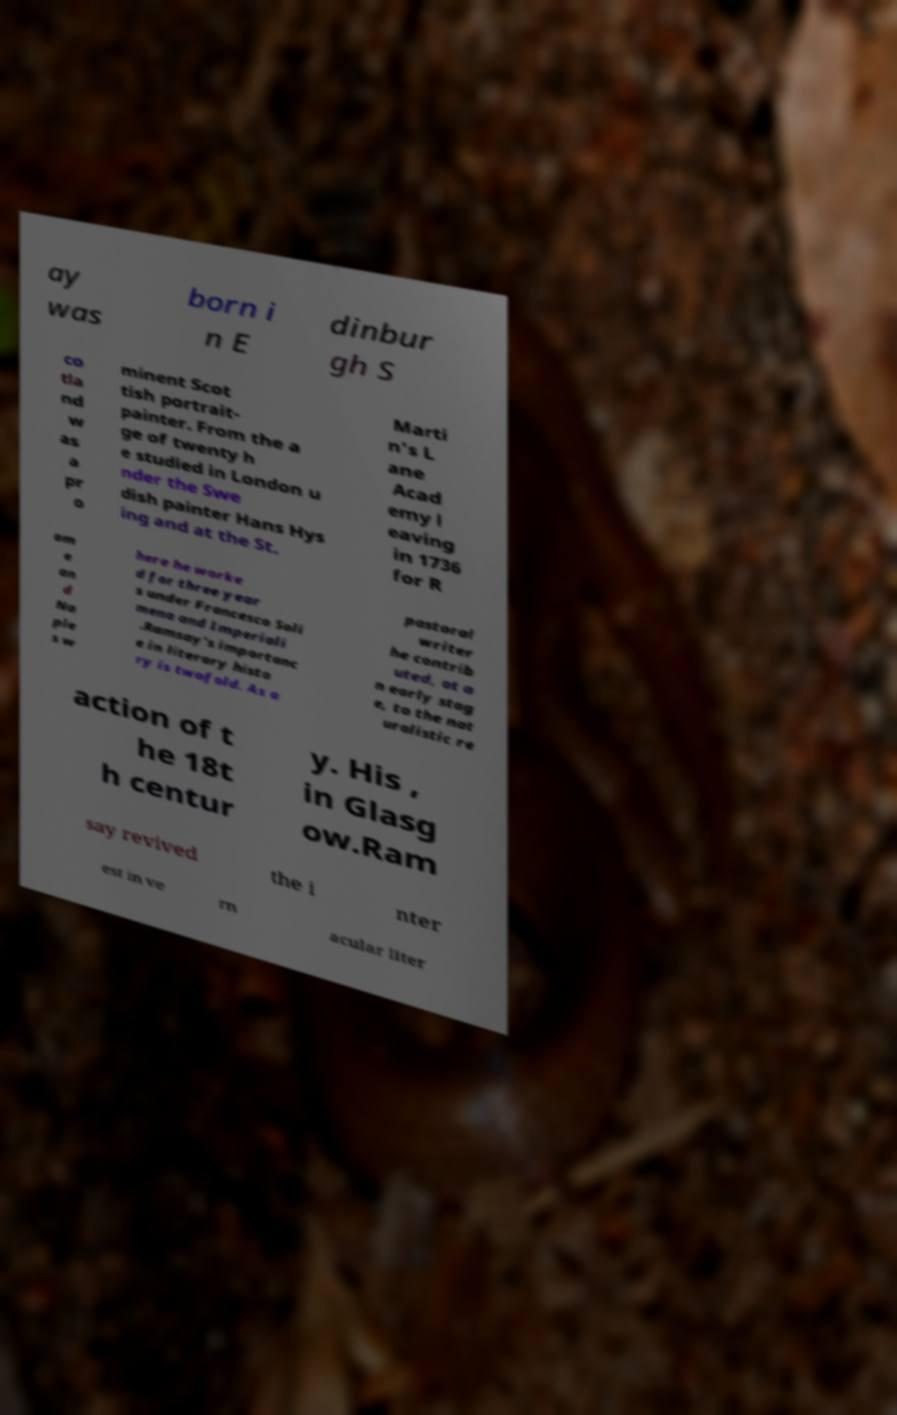I need the written content from this picture converted into text. Can you do that? ay was born i n E dinbur gh S co tla nd w as a pr o minent Scot tish portrait- painter. From the a ge of twenty h e studied in London u nder the Swe dish painter Hans Hys ing and at the St. Marti n's L ane Acad emy l eaving in 1736 for R om e an d Na ple s w here he worke d for three year s under Francesco Soli mena and Imperiali .Ramsay's importanc e in literary histo ry is twofold. As a pastoral writer he contrib uted, at a n early stag e, to the nat uralistic re action of t he 18t h centur y. His , in Glasg ow.Ram say revived the i nter est in ve rn acular liter 